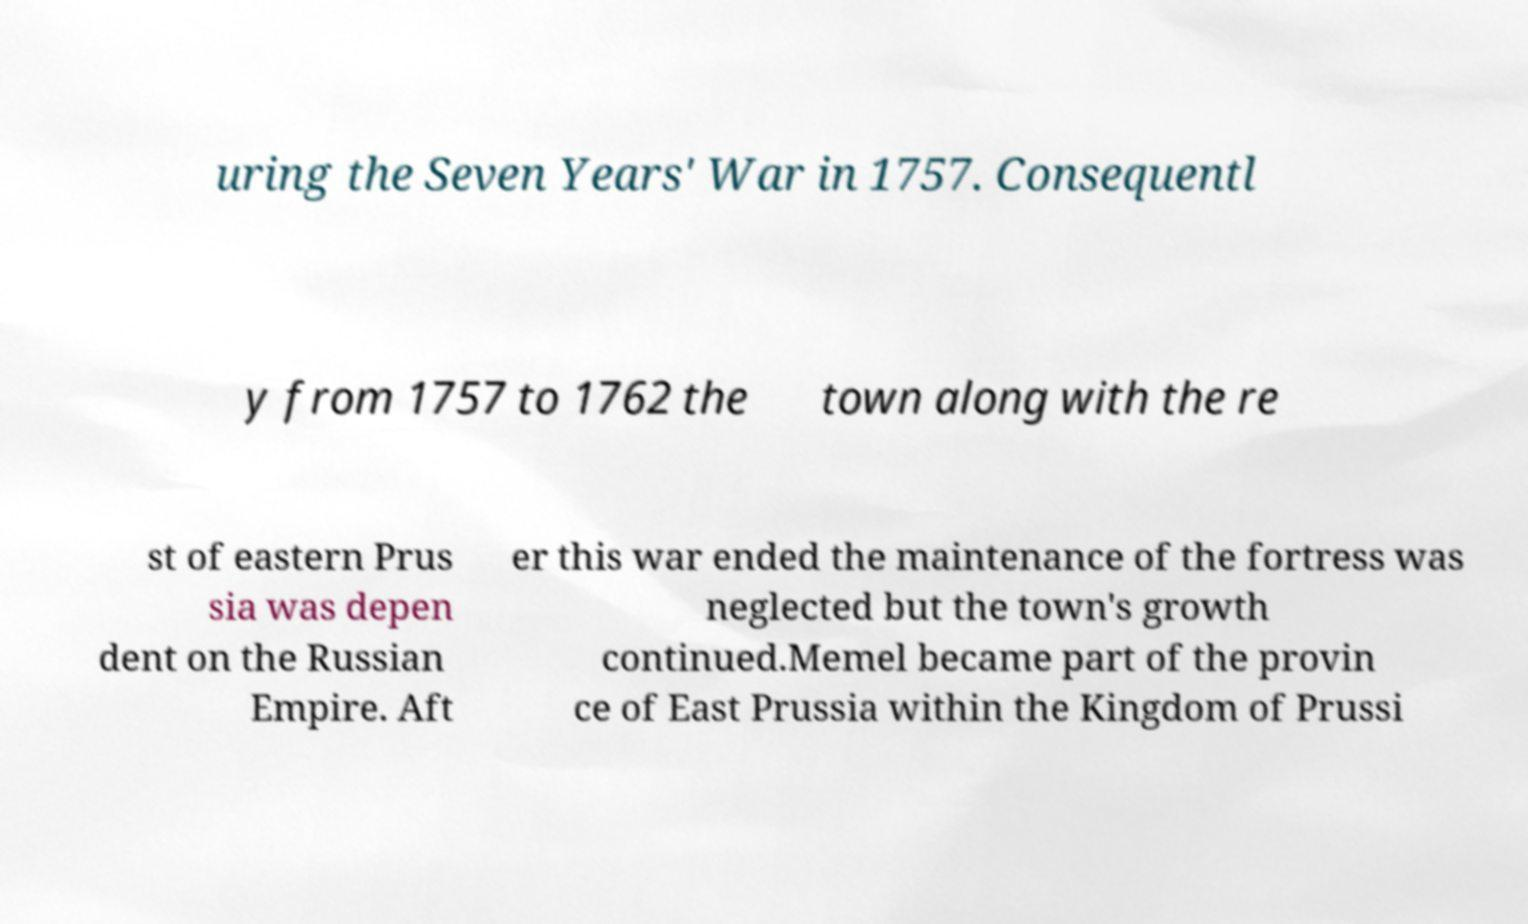I need the written content from this picture converted into text. Can you do that? uring the Seven Years' War in 1757. Consequentl y from 1757 to 1762 the town along with the re st of eastern Prus sia was depen dent on the Russian Empire. Aft er this war ended the maintenance of the fortress was neglected but the town's growth continued.Memel became part of the provin ce of East Prussia within the Kingdom of Prussi 